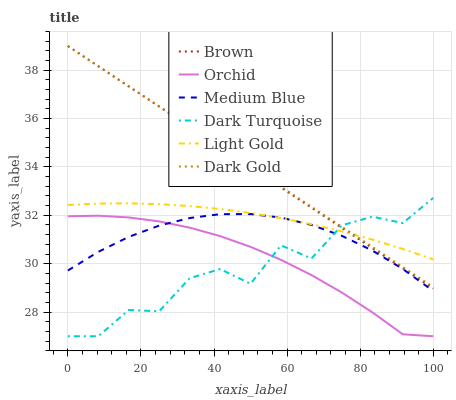Does Dark Turquoise have the minimum area under the curve?
Answer yes or no. Yes. Does Dark Gold have the maximum area under the curve?
Answer yes or no. Yes. Does Dark Gold have the minimum area under the curve?
Answer yes or no. No. Does Dark Turquoise have the maximum area under the curve?
Answer yes or no. No. Is Dark Gold the smoothest?
Answer yes or no. Yes. Is Dark Turquoise the roughest?
Answer yes or no. Yes. Is Dark Turquoise the smoothest?
Answer yes or no. No. Is Dark Gold the roughest?
Answer yes or no. No. Does Dark Gold have the lowest value?
Answer yes or no. No. Does Dark Gold have the highest value?
Answer yes or no. Yes. Does Dark Turquoise have the highest value?
Answer yes or no. No. Is Medium Blue less than Dark Gold?
Answer yes or no. Yes. Is Dark Gold greater than Orchid?
Answer yes or no. Yes. Does Brown intersect Dark Turquoise?
Answer yes or no. Yes. Is Brown less than Dark Turquoise?
Answer yes or no. No. Is Brown greater than Dark Turquoise?
Answer yes or no. No. Does Medium Blue intersect Dark Gold?
Answer yes or no. No. 